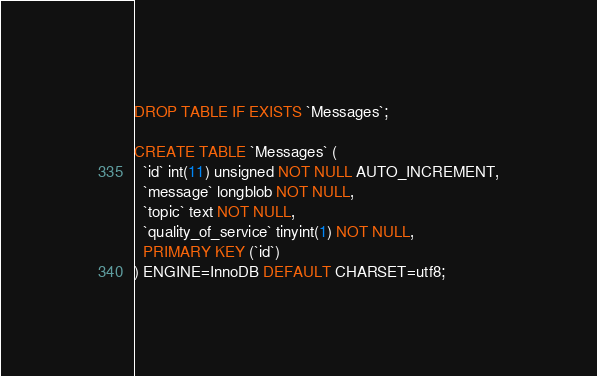Convert code to text. <code><loc_0><loc_0><loc_500><loc_500><_SQL_>DROP TABLE IF EXISTS `Messages`;

CREATE TABLE `Messages` (
  `id` int(11) unsigned NOT NULL AUTO_INCREMENT,
  `message` longblob NOT NULL,
  `topic` text NOT NULL,
  `quality_of_service` tinyint(1) NOT NULL,
  PRIMARY KEY (`id`)
) ENGINE=InnoDB DEFAULT CHARSET=utf8;

</code> 